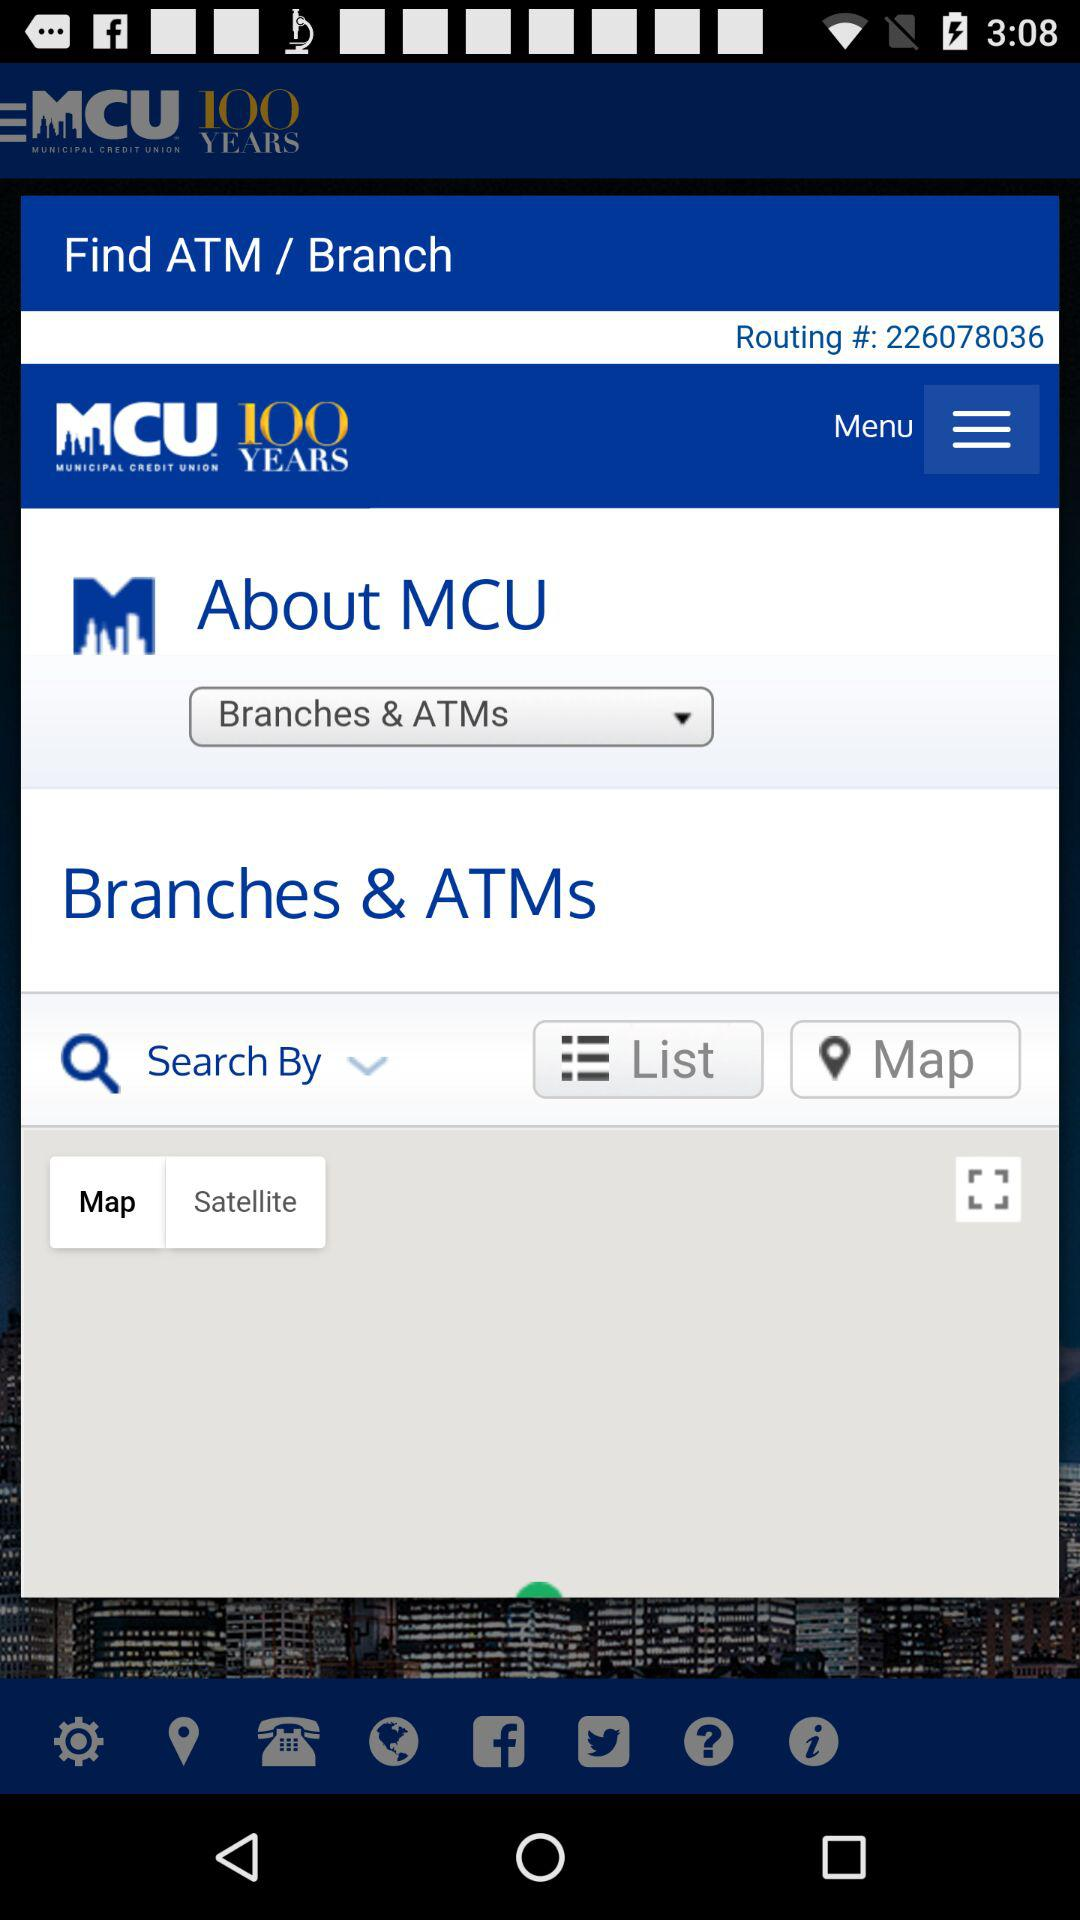What is the routing number? The routing number is 226078036. 